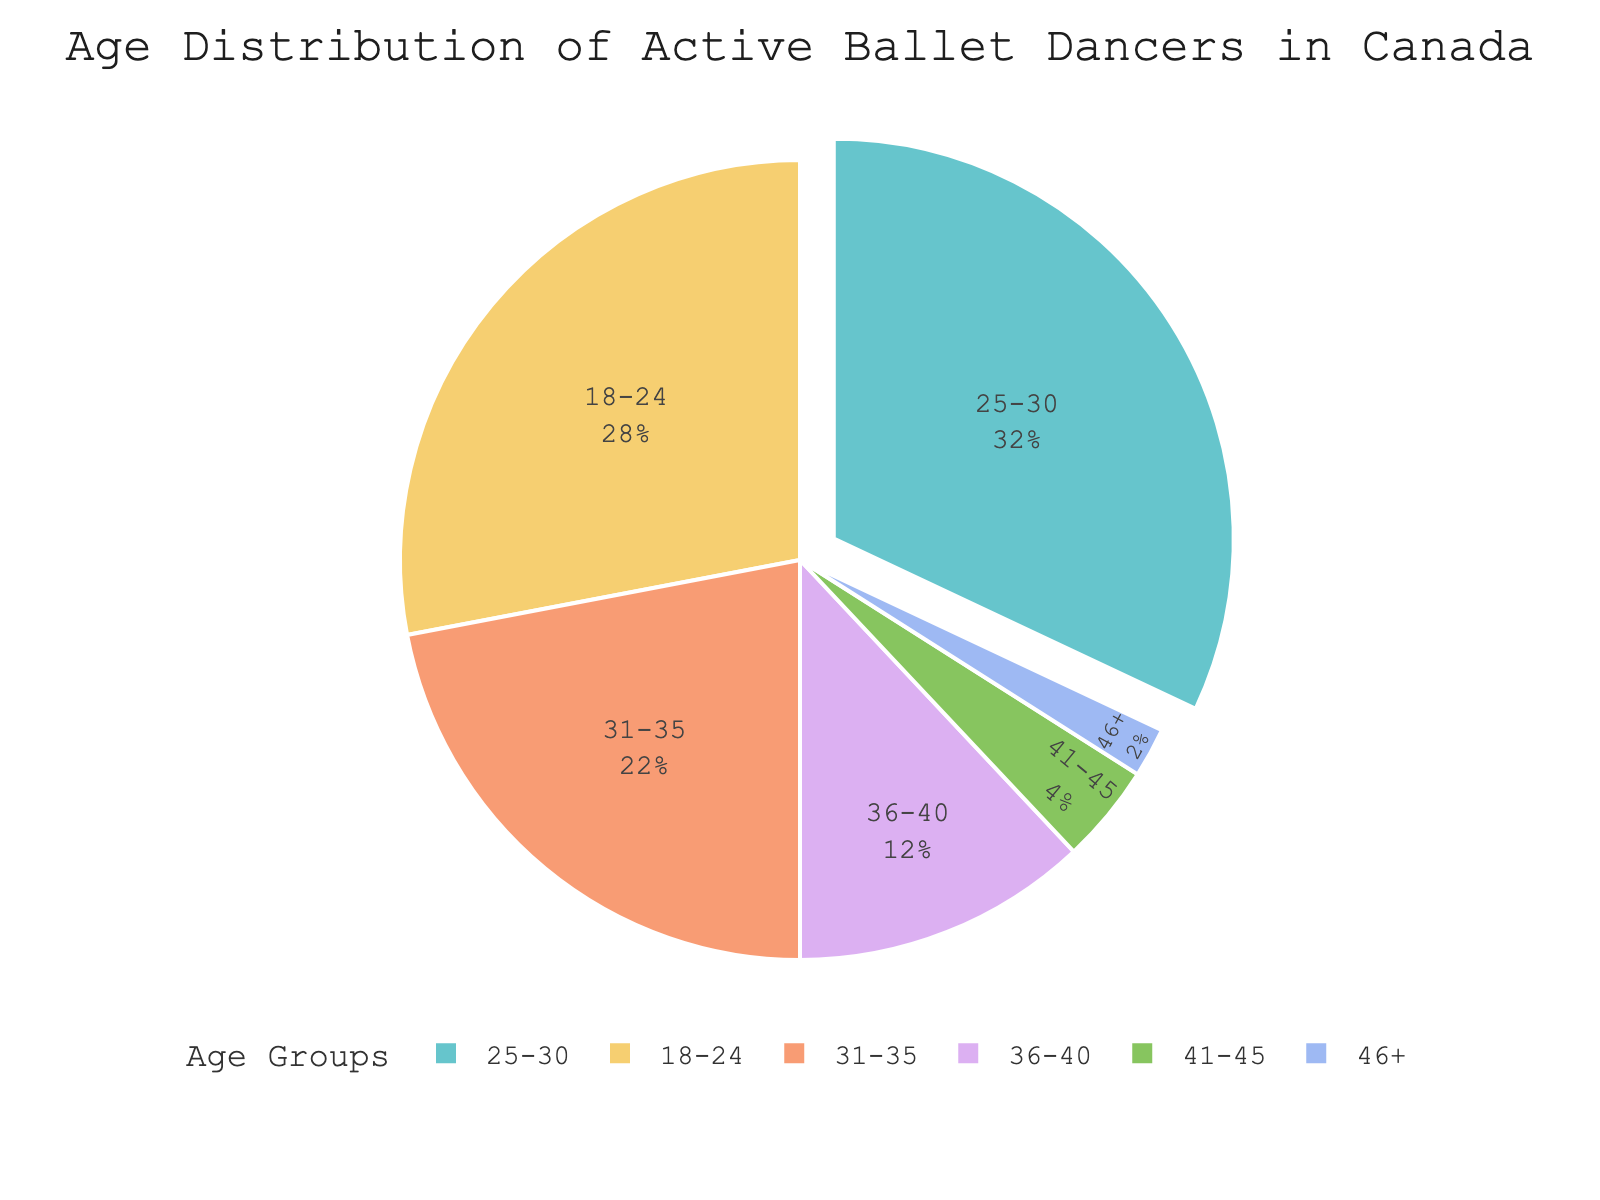Which age group has the highest percentage of active ballet dancers in Canada? By observing the pie chart, determine which slice is the largest. The slice representing the 25-30 age group occupies the largest portion of the pie.
Answer: 25-30 Which two age groups together make up half of the active ballet dancers in Canada? Look for age groups whose percentages sum up to 50%. The 18-24 group and 25-30 group together are 28% + 32% = 60%, but selecting the 18-24 group and 31-35 group yields 28% + 22% = 50%.
Answer: - 18-24 and 31-35 What's the difference in percentage between the 25-30 and 36-40 age groups? Subtract the percentage of the 36-40 age group from the percentage of the 25-30 group. This is 32% - 12% = 20%.
Answer: 20% Which age group has the smallest representation among active ballet dancers in Canada? Identify the smallest slice in the pie chart. The slice for the 46+ age group is the smallest.
Answer: 46+ How many age groups have a representation of less than 10%? Count the slices that represent less than 10% each. The age groups are 41-45 and 46+. That's two age groups.
Answer: 2 What is the combined percentage of ballet dancers aged 36 and older? Add the percentages of the 36-40, 41-45, and 46+ age groups. 12% + 4% + 2% = 18%.
Answer: 18% Which age group color is located next to the 31-35 category in the pie chart? Visually locate the 31-35 section and identify the adjacent colored slice. The adjacent slices are 25-30 and 36-40 (assuming clockwise or counterclockwise).
Answer: 25-30 and 36-40 Do the youngest and oldest age groups together account for more or less than one-third of the total dancers? Add the percentages of the 18-24 and 46+ age groups and compare to 33.33%. 28% + 2% = 30%, which is less than a third.
Answer: Less Is the percentage of dancers in the 25-30 group more than twice that of the 31-35 group? Double the percentage of the 31-35 group and compare with the 25-30 group. 2 * 22% = 44%, which is greater than 32%. Therefore, no.
Answer: No 